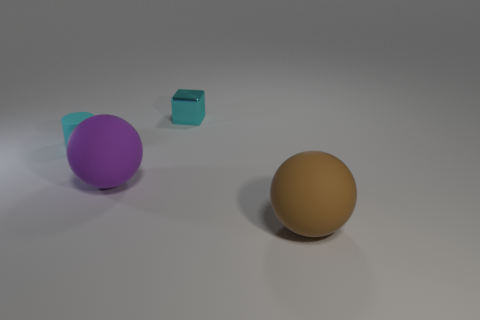Add 4 purple balls. How many objects exist? 8 Subtract all purple balls. How many balls are left? 1 Subtract 1 spheres. How many spheres are left? 1 Add 3 big purple spheres. How many big purple spheres are left? 4 Add 1 small red metallic objects. How many small red metallic objects exist? 1 Subtract 0 brown cylinders. How many objects are left? 4 Subtract all cubes. How many objects are left? 3 Subtract all gray cylinders. Subtract all green balls. How many cylinders are left? 1 Subtract all big yellow cylinders. Subtract all cyan blocks. How many objects are left? 3 